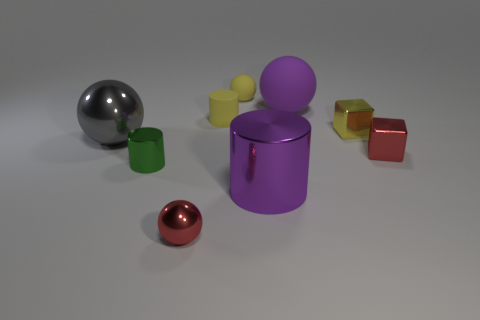Add 1 yellow cylinders. How many objects exist? 10 Subtract all cubes. How many objects are left? 7 Subtract 0 brown balls. How many objects are left? 9 Subtract all small brown metal objects. Subtract all big metallic balls. How many objects are left? 8 Add 1 big purple matte things. How many big purple matte things are left? 2 Add 3 red metallic things. How many red metallic things exist? 5 